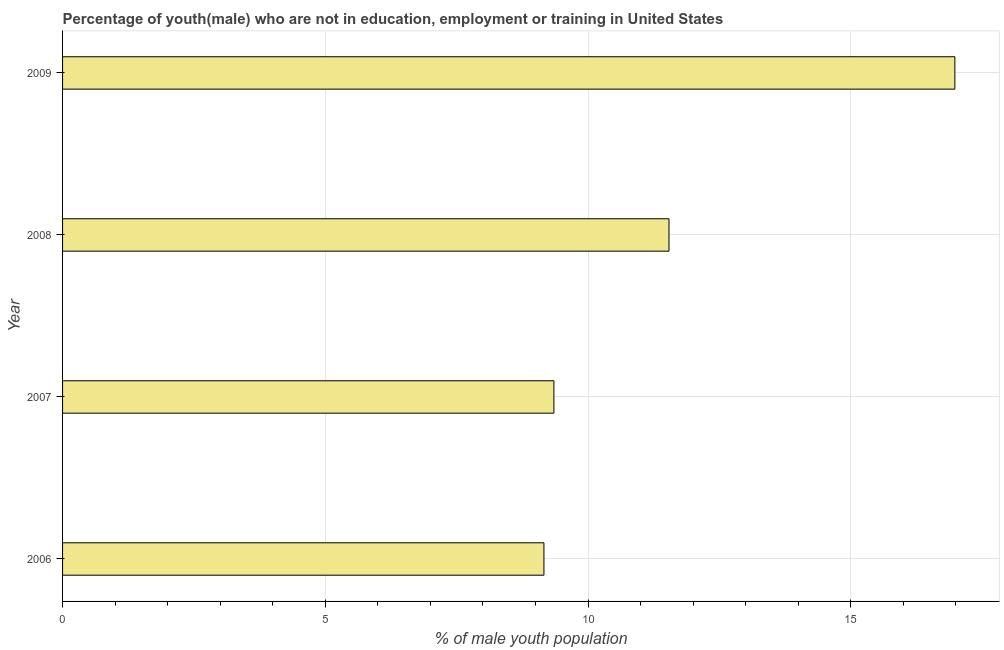What is the title of the graph?
Provide a succinct answer. Percentage of youth(male) who are not in education, employment or training in United States. What is the label or title of the X-axis?
Your answer should be compact. % of male youth population. What is the label or title of the Y-axis?
Your answer should be compact. Year. What is the unemployed male youth population in 2007?
Keep it short and to the point. 9.35. Across all years, what is the maximum unemployed male youth population?
Your response must be concise. 16.98. Across all years, what is the minimum unemployed male youth population?
Make the answer very short. 9.16. In which year was the unemployed male youth population maximum?
Provide a succinct answer. 2009. In which year was the unemployed male youth population minimum?
Make the answer very short. 2006. What is the sum of the unemployed male youth population?
Ensure brevity in your answer.  47.03. What is the difference between the unemployed male youth population in 2007 and 2008?
Offer a terse response. -2.19. What is the average unemployed male youth population per year?
Keep it short and to the point. 11.76. What is the median unemployed male youth population?
Your answer should be very brief. 10.45. In how many years, is the unemployed male youth population greater than 6 %?
Provide a succinct answer. 4. Do a majority of the years between 2008 and 2009 (inclusive) have unemployed male youth population greater than 7 %?
Your answer should be compact. Yes. What is the ratio of the unemployed male youth population in 2007 to that in 2008?
Your answer should be compact. 0.81. Is the unemployed male youth population in 2006 less than that in 2008?
Ensure brevity in your answer.  Yes. What is the difference between the highest and the second highest unemployed male youth population?
Your response must be concise. 5.44. Is the sum of the unemployed male youth population in 2006 and 2008 greater than the maximum unemployed male youth population across all years?
Your response must be concise. Yes. What is the difference between the highest and the lowest unemployed male youth population?
Make the answer very short. 7.82. In how many years, is the unemployed male youth population greater than the average unemployed male youth population taken over all years?
Your answer should be very brief. 1. What is the difference between two consecutive major ticks on the X-axis?
Ensure brevity in your answer.  5. What is the % of male youth population in 2006?
Keep it short and to the point. 9.16. What is the % of male youth population of 2007?
Offer a very short reply. 9.35. What is the % of male youth population in 2008?
Give a very brief answer. 11.54. What is the % of male youth population of 2009?
Offer a very short reply. 16.98. What is the difference between the % of male youth population in 2006 and 2007?
Your response must be concise. -0.19. What is the difference between the % of male youth population in 2006 and 2008?
Ensure brevity in your answer.  -2.38. What is the difference between the % of male youth population in 2006 and 2009?
Your response must be concise. -7.82. What is the difference between the % of male youth population in 2007 and 2008?
Your response must be concise. -2.19. What is the difference between the % of male youth population in 2007 and 2009?
Your answer should be very brief. -7.63. What is the difference between the % of male youth population in 2008 and 2009?
Your response must be concise. -5.44. What is the ratio of the % of male youth population in 2006 to that in 2008?
Offer a terse response. 0.79. What is the ratio of the % of male youth population in 2006 to that in 2009?
Provide a succinct answer. 0.54. What is the ratio of the % of male youth population in 2007 to that in 2008?
Your answer should be very brief. 0.81. What is the ratio of the % of male youth population in 2007 to that in 2009?
Provide a succinct answer. 0.55. What is the ratio of the % of male youth population in 2008 to that in 2009?
Ensure brevity in your answer.  0.68. 